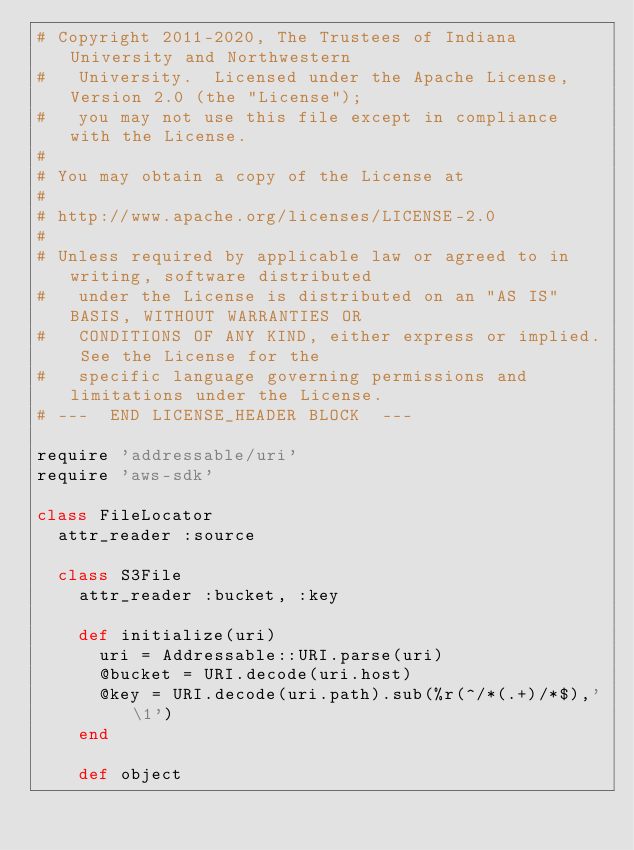<code> <loc_0><loc_0><loc_500><loc_500><_Ruby_># Copyright 2011-2020, The Trustees of Indiana University and Northwestern
#   University.  Licensed under the Apache License, Version 2.0 (the "License");
#   you may not use this file except in compliance with the License.
#
# You may obtain a copy of the License at
#
# http://www.apache.org/licenses/LICENSE-2.0
#
# Unless required by applicable law or agreed to in writing, software distributed
#   under the License is distributed on an "AS IS" BASIS, WITHOUT WARRANTIES OR
#   CONDITIONS OF ANY KIND, either express or implied. See the License for the
#   specific language governing permissions and limitations under the License.
# ---  END LICENSE_HEADER BLOCK  ---

require 'addressable/uri'
require 'aws-sdk'

class FileLocator
  attr_reader :source

  class S3File
    attr_reader :bucket, :key

    def initialize(uri)
      uri = Addressable::URI.parse(uri)
      @bucket = URI.decode(uri.host)
      @key = URI.decode(uri.path).sub(%r(^/*(.+)/*$),'\1')
    end

    def object</code> 